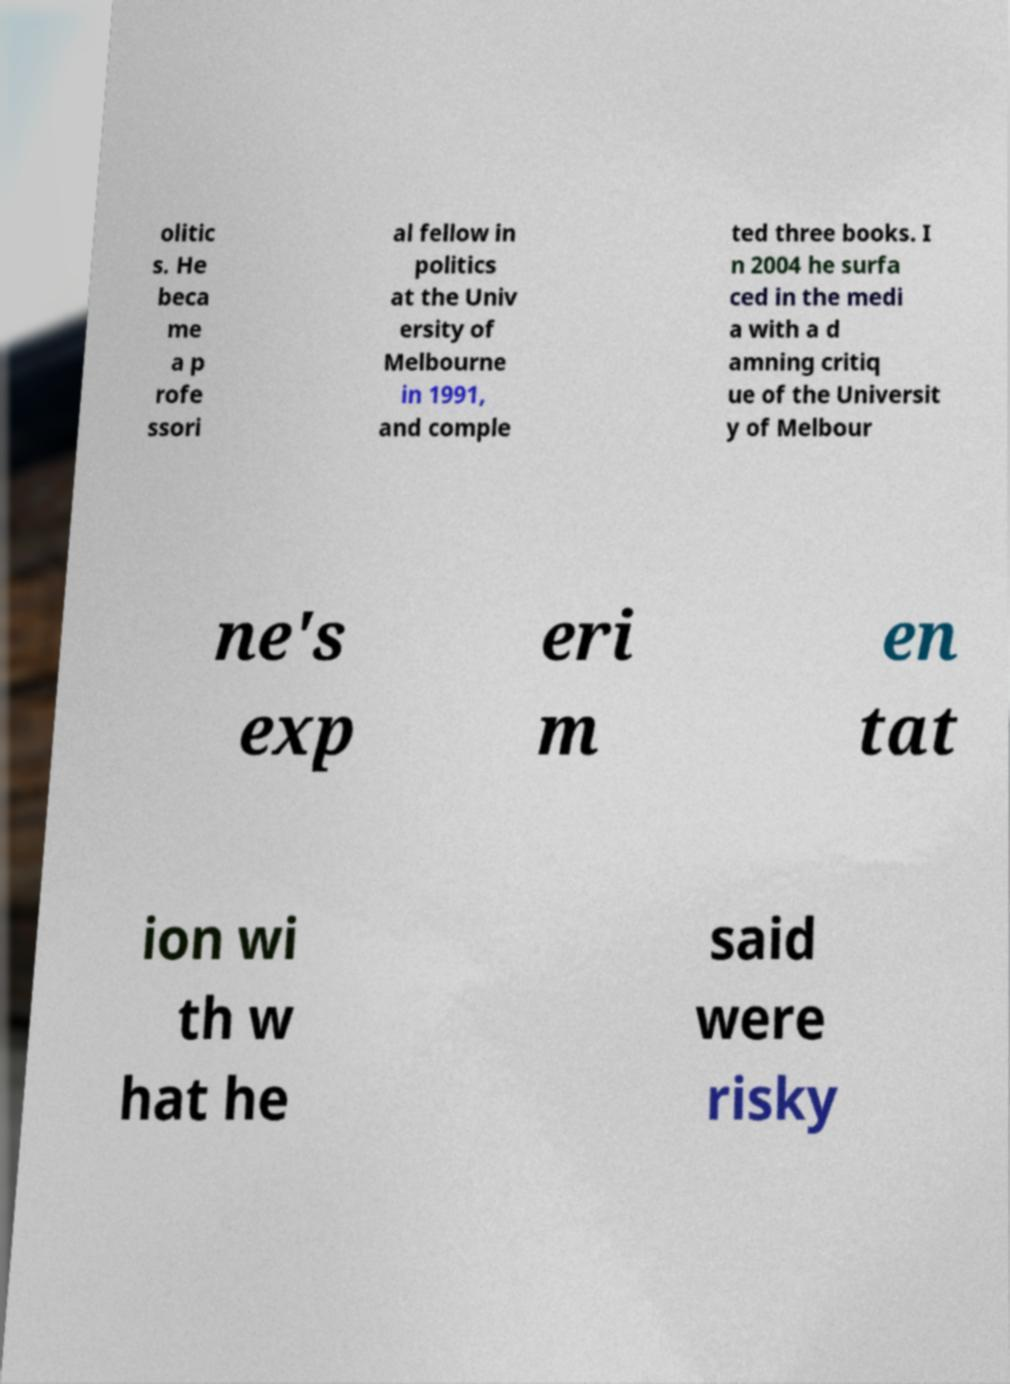Can you read and provide the text displayed in the image?This photo seems to have some interesting text. Can you extract and type it out for me? olitic s. He beca me a p rofe ssori al fellow in politics at the Univ ersity of Melbourne in 1991, and comple ted three books. I n 2004 he surfa ced in the medi a with a d amning critiq ue of the Universit y of Melbour ne's exp eri m en tat ion wi th w hat he said were risky 